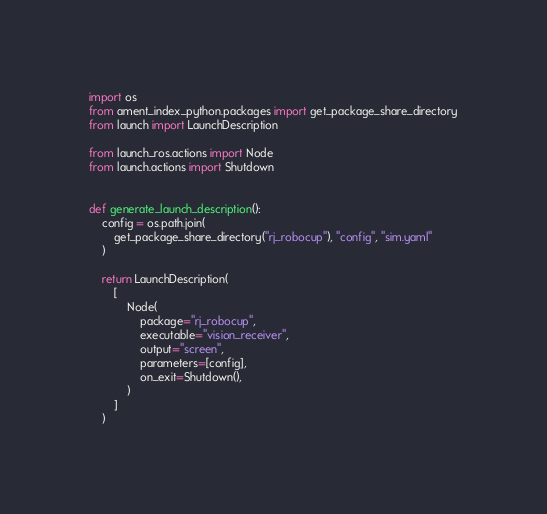<code> <loc_0><loc_0><loc_500><loc_500><_Python_>import os
from ament_index_python.packages import get_package_share_directory
from launch import LaunchDescription

from launch_ros.actions import Node
from launch.actions import Shutdown


def generate_launch_description():
    config = os.path.join(
        get_package_share_directory("rj_robocup"), "config", "sim.yaml"
    )

    return LaunchDescription(
        [
            Node(
                package="rj_robocup",
                executable="vision_receiver",
                output="screen",
                parameters=[config],
                on_exit=Shutdown(),
            )
        ]
    )
</code> 